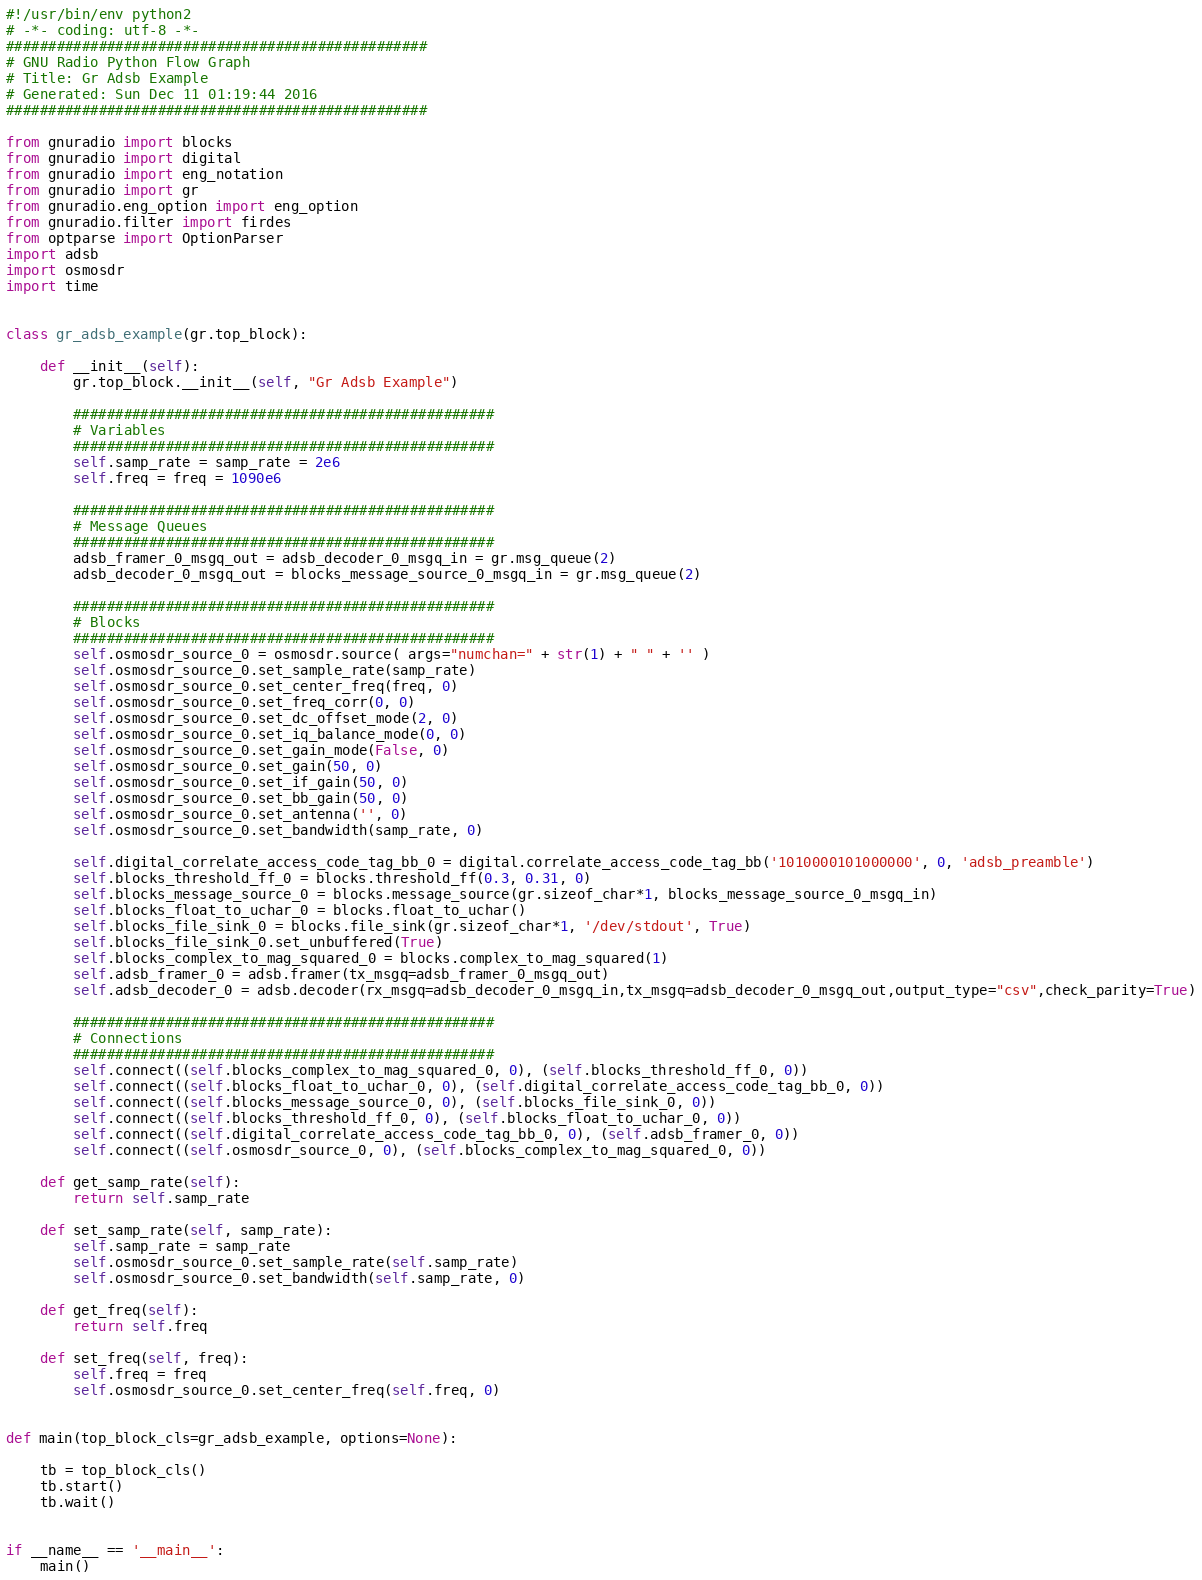<code> <loc_0><loc_0><loc_500><loc_500><_Python_>#!/usr/bin/env python2
# -*- coding: utf-8 -*-
##################################################
# GNU Radio Python Flow Graph
# Title: Gr Adsb Example
# Generated: Sun Dec 11 01:19:44 2016
##################################################

from gnuradio import blocks
from gnuradio import digital
from gnuradio import eng_notation
from gnuradio import gr
from gnuradio.eng_option import eng_option
from gnuradio.filter import firdes
from optparse import OptionParser
import adsb
import osmosdr
import time


class gr_adsb_example(gr.top_block):

    def __init__(self):
        gr.top_block.__init__(self, "Gr Adsb Example")

        ##################################################
        # Variables
        ##################################################
        self.samp_rate = samp_rate = 2e6
        self.freq = freq = 1090e6

        ##################################################
        # Message Queues
        ##################################################
        adsb_framer_0_msgq_out = adsb_decoder_0_msgq_in = gr.msg_queue(2)
        adsb_decoder_0_msgq_out = blocks_message_source_0_msgq_in = gr.msg_queue(2)

        ##################################################
        # Blocks
        ##################################################
        self.osmosdr_source_0 = osmosdr.source( args="numchan=" + str(1) + " " + '' )
        self.osmosdr_source_0.set_sample_rate(samp_rate)
        self.osmosdr_source_0.set_center_freq(freq, 0)
        self.osmosdr_source_0.set_freq_corr(0, 0)
        self.osmosdr_source_0.set_dc_offset_mode(2, 0)
        self.osmosdr_source_0.set_iq_balance_mode(0, 0)
        self.osmosdr_source_0.set_gain_mode(False, 0)
        self.osmosdr_source_0.set_gain(50, 0)
        self.osmosdr_source_0.set_if_gain(50, 0)
        self.osmosdr_source_0.set_bb_gain(50, 0)
        self.osmosdr_source_0.set_antenna('', 0)
        self.osmosdr_source_0.set_bandwidth(samp_rate, 0)
          
        self.digital_correlate_access_code_tag_bb_0 = digital.correlate_access_code_tag_bb('1010000101000000', 0, 'adsb_preamble')
        self.blocks_threshold_ff_0 = blocks.threshold_ff(0.3, 0.31, 0)
        self.blocks_message_source_0 = blocks.message_source(gr.sizeof_char*1, blocks_message_source_0_msgq_in)
        self.blocks_float_to_uchar_0 = blocks.float_to_uchar()
        self.blocks_file_sink_0 = blocks.file_sink(gr.sizeof_char*1, '/dev/stdout', True)
        self.blocks_file_sink_0.set_unbuffered(True)
        self.blocks_complex_to_mag_squared_0 = blocks.complex_to_mag_squared(1)
        self.adsb_framer_0 = adsb.framer(tx_msgq=adsb_framer_0_msgq_out)
        self.adsb_decoder_0 = adsb.decoder(rx_msgq=adsb_decoder_0_msgq_in,tx_msgq=adsb_decoder_0_msgq_out,output_type="csv",check_parity=True)

        ##################################################
        # Connections
        ##################################################
        self.connect((self.blocks_complex_to_mag_squared_0, 0), (self.blocks_threshold_ff_0, 0))    
        self.connect((self.blocks_float_to_uchar_0, 0), (self.digital_correlate_access_code_tag_bb_0, 0))    
        self.connect((self.blocks_message_source_0, 0), (self.blocks_file_sink_0, 0))    
        self.connect((self.blocks_threshold_ff_0, 0), (self.blocks_float_to_uchar_0, 0))    
        self.connect((self.digital_correlate_access_code_tag_bb_0, 0), (self.adsb_framer_0, 0))    
        self.connect((self.osmosdr_source_0, 0), (self.blocks_complex_to_mag_squared_0, 0))    

    def get_samp_rate(self):
        return self.samp_rate

    def set_samp_rate(self, samp_rate):
        self.samp_rate = samp_rate
        self.osmosdr_source_0.set_sample_rate(self.samp_rate)
        self.osmosdr_source_0.set_bandwidth(self.samp_rate, 0)

    def get_freq(self):
        return self.freq

    def set_freq(self, freq):
        self.freq = freq
        self.osmosdr_source_0.set_center_freq(self.freq, 0)


def main(top_block_cls=gr_adsb_example, options=None):

    tb = top_block_cls()
    tb.start()
    tb.wait()


if __name__ == '__main__':
    main()
</code> 